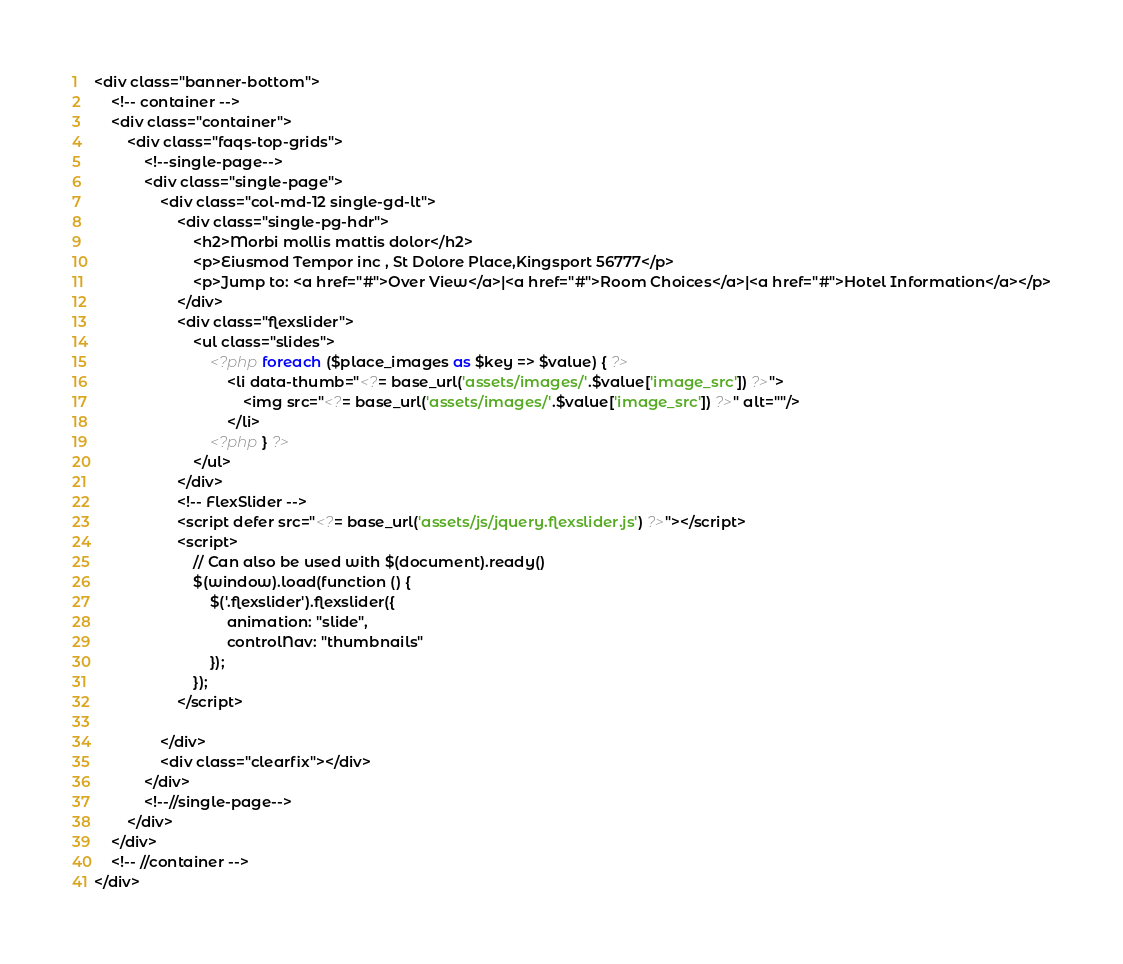Convert code to text. <code><loc_0><loc_0><loc_500><loc_500><_PHP_><div class="banner-bottom">
    <!-- container -->
    <div class="container">
        <div class="faqs-top-grids">
            <!--single-page-->
            <div class="single-page">
                <div class="col-md-12 single-gd-lt">
                    <div class="single-pg-hdr">
                        <h2>Morbi mollis mattis dolor</h2>
                        <p>Eiusmod Tempor inc , St Dolore Place,Kingsport 56777</p>
                        <p>Jump to: <a href="#">Over View</a>|<a href="#">Room Choices</a>|<a href="#">Hotel Information</a></p>
                    </div>
                    <div class="flexslider">
                        <ul class="slides">
                            <?php foreach ($place_images as $key => $value) { ?>
                                <li data-thumb="<?= base_url('assets/images/'.$value['image_src']) ?>">
                                    <img src="<?= base_url('assets/images/'.$value['image_src']) ?>" alt=""/>
                                </li>
                            <?php } ?>
                        </ul>
                    </div>
                    <!-- FlexSlider -->
                    <script defer src="<?= base_url('assets/js/jquery.flexslider.js') ?>"></script>
                    <script>
                        // Can also be used with $(document).ready()
                        $(window).load(function () {
                            $('.flexslider').flexslider({
                                animation: "slide",
                                controlNav: "thumbnails"
                            });
                        });
                    </script>

                </div>
                <div class="clearfix"></div>
            </div>
            <!--//single-page-->
        </div>
    </div>
    <!-- //container -->
</div></code> 